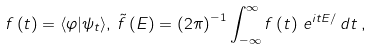Convert formula to latex. <formula><loc_0><loc_0><loc_500><loc_500>f \left ( t \right ) = \langle \varphi | \psi _ { t } \rangle , \, \tilde { f } \left ( E \right ) = \left ( 2 \pi \right ) ^ { - 1 } \int _ { - \infty } ^ { \infty } f \left ( t \right ) \, e ^ { i t E / } \, d t \, ,</formula> 